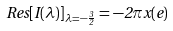Convert formula to latex. <formula><loc_0><loc_0><loc_500><loc_500>R e s [ I ( \lambda ) ] _ { \lambda = - \frac { 3 } { 2 } } = - 2 \pi x ( e )</formula> 